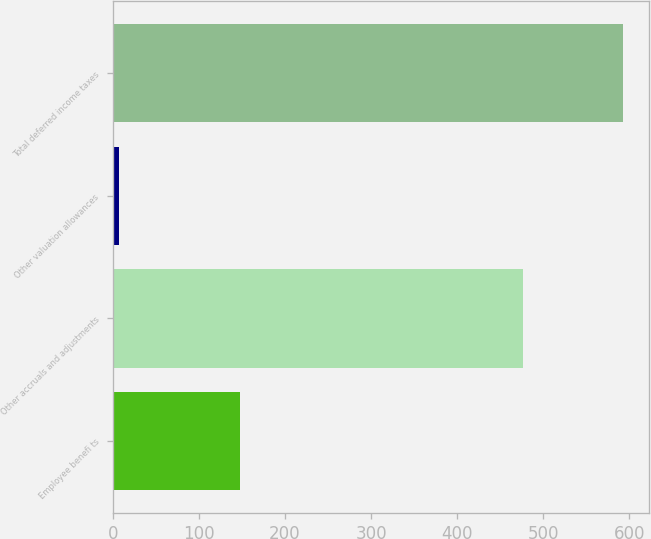Convert chart. <chart><loc_0><loc_0><loc_500><loc_500><bar_chart><fcel>Employee benefi ts<fcel>Other accruals and adjustments<fcel>Other valuation allowances<fcel>Total deferred income taxes<nl><fcel>148<fcel>476<fcel>7<fcel>593<nl></chart> 